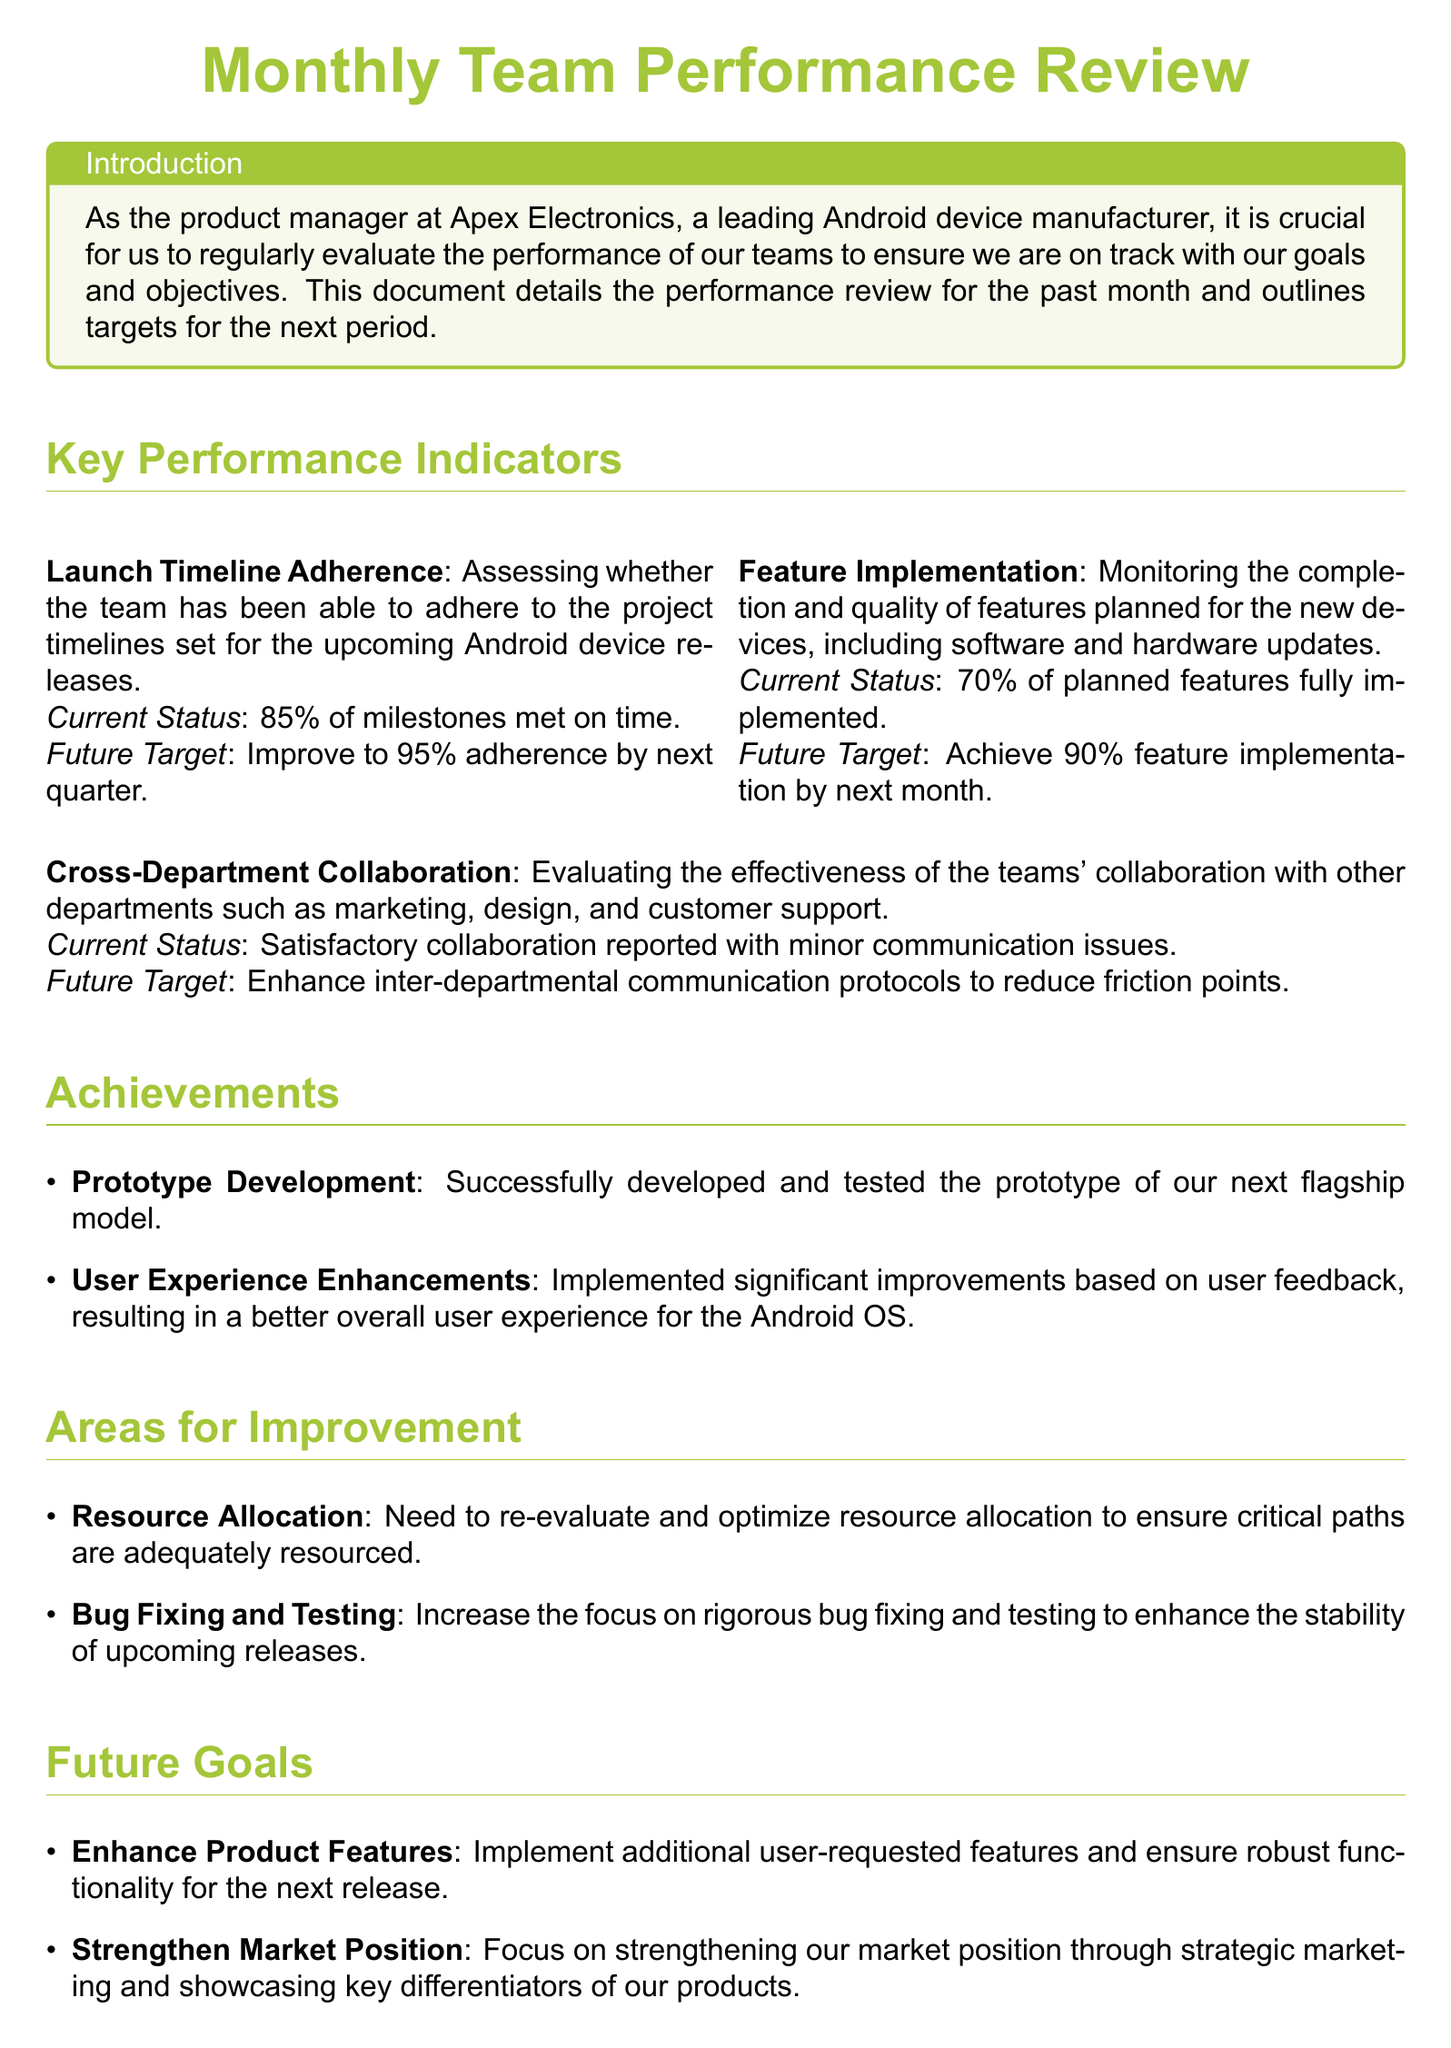What is the current status of Launch Timeline Adherence? The current status of Launch Timeline Adherence indicates that 85% of milestones have been met on time.
Answer: 85% What is the future target for Feature Implementation? The future target for Feature Implementation is to achieve 90% feature implementation by next month.
Answer: 90% What was one of the achievements related to User Experience? One achievement related to User Experience was the implementation of significant improvements based on user feedback.
Answer: Improvements based on user feedback What is an area for improvement regarding Resource Allocation? An area for improvement regarding Resource Allocation states the need to re-evaluate and optimize resource allocation.
Answer: Re-evaluate and optimize What goal is set to boost Team Morale? The goal set to boost Team Morale is to initiate team-building activities and provide professional development opportunities.
Answer: Team-building activities What percentage of planned features was fully implemented? The document states that 70% of planned features were fully implemented.
Answer: 70% What minor issue was reported during Cross-Department Collaboration? The document mentions that minor communication issues were reported during Cross-Department Collaboration.
Answer: Minor communication issues What conclusion is drawn about the performance review? The conclusion drawn about the performance review is that there is steady progress but areas require immediate attention.
Answer: Steady progress Which department collaborated effectively with the teams according to the review? The review states satisfactory collaboration reported with departments like marketing, design, and customer support.
Answer: Marketing, design, and customer support What is the primary focus of Future Goals regarding Market Position? The primary focus of Future Goals regarding Market Position is to strengthen it through strategic marketing.
Answer: Strengthening through strategic marketing 